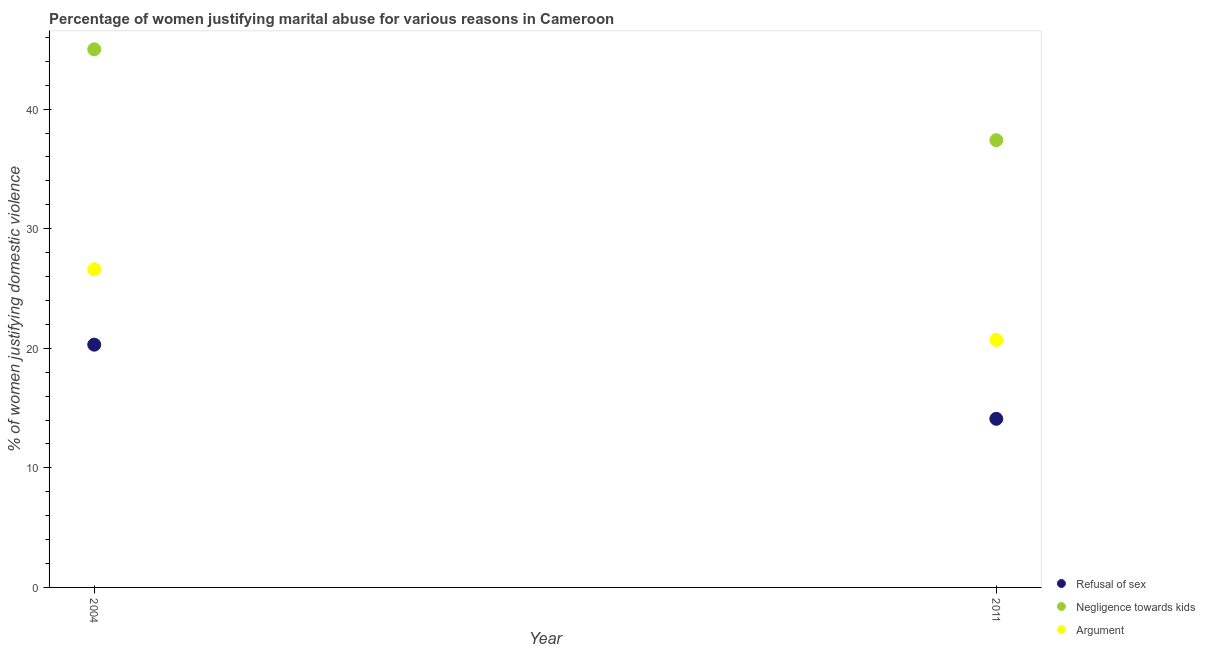Is the number of dotlines equal to the number of legend labels?
Ensure brevity in your answer.  Yes. What is the percentage of women justifying domestic violence due to negligence towards kids in 2004?
Make the answer very short. 45. Across all years, what is the minimum percentage of women justifying domestic violence due to arguments?
Make the answer very short. 20.7. In which year was the percentage of women justifying domestic violence due to arguments maximum?
Offer a very short reply. 2004. In which year was the percentage of women justifying domestic violence due to refusal of sex minimum?
Provide a succinct answer. 2011. What is the total percentage of women justifying domestic violence due to negligence towards kids in the graph?
Make the answer very short. 82.4. What is the difference between the percentage of women justifying domestic violence due to negligence towards kids in 2004 and that in 2011?
Your answer should be very brief. 7.6. What is the difference between the percentage of women justifying domestic violence due to negligence towards kids in 2011 and the percentage of women justifying domestic violence due to arguments in 2004?
Offer a very short reply. 10.8. What is the average percentage of women justifying domestic violence due to arguments per year?
Your answer should be very brief. 23.65. In the year 2011, what is the difference between the percentage of women justifying domestic violence due to refusal of sex and percentage of women justifying domestic violence due to arguments?
Your response must be concise. -6.6. What is the ratio of the percentage of women justifying domestic violence due to arguments in 2004 to that in 2011?
Make the answer very short. 1.29. Is it the case that in every year, the sum of the percentage of women justifying domestic violence due to refusal of sex and percentage of women justifying domestic violence due to negligence towards kids is greater than the percentage of women justifying domestic violence due to arguments?
Provide a short and direct response. Yes. Does the percentage of women justifying domestic violence due to negligence towards kids monotonically increase over the years?
Provide a succinct answer. No. Is the percentage of women justifying domestic violence due to negligence towards kids strictly greater than the percentage of women justifying domestic violence due to refusal of sex over the years?
Offer a very short reply. Yes. How many years are there in the graph?
Ensure brevity in your answer.  2. What is the difference between two consecutive major ticks on the Y-axis?
Offer a terse response. 10. Does the graph contain grids?
Provide a short and direct response. No. How many legend labels are there?
Make the answer very short. 3. How are the legend labels stacked?
Provide a short and direct response. Vertical. What is the title of the graph?
Keep it short and to the point. Percentage of women justifying marital abuse for various reasons in Cameroon. What is the label or title of the X-axis?
Ensure brevity in your answer.  Year. What is the label or title of the Y-axis?
Provide a short and direct response. % of women justifying domestic violence. What is the % of women justifying domestic violence of Refusal of sex in 2004?
Keep it short and to the point. 20.3. What is the % of women justifying domestic violence of Negligence towards kids in 2004?
Your answer should be compact. 45. What is the % of women justifying domestic violence of Argument in 2004?
Ensure brevity in your answer.  26.6. What is the % of women justifying domestic violence of Negligence towards kids in 2011?
Make the answer very short. 37.4. What is the % of women justifying domestic violence in Argument in 2011?
Your answer should be very brief. 20.7. Across all years, what is the maximum % of women justifying domestic violence in Refusal of sex?
Your response must be concise. 20.3. Across all years, what is the maximum % of women justifying domestic violence of Negligence towards kids?
Give a very brief answer. 45. Across all years, what is the maximum % of women justifying domestic violence of Argument?
Offer a terse response. 26.6. Across all years, what is the minimum % of women justifying domestic violence of Negligence towards kids?
Your response must be concise. 37.4. Across all years, what is the minimum % of women justifying domestic violence in Argument?
Make the answer very short. 20.7. What is the total % of women justifying domestic violence in Refusal of sex in the graph?
Make the answer very short. 34.4. What is the total % of women justifying domestic violence of Negligence towards kids in the graph?
Offer a terse response. 82.4. What is the total % of women justifying domestic violence in Argument in the graph?
Your response must be concise. 47.3. What is the difference between the % of women justifying domestic violence of Negligence towards kids in 2004 and that in 2011?
Offer a very short reply. 7.6. What is the difference between the % of women justifying domestic violence of Refusal of sex in 2004 and the % of women justifying domestic violence of Negligence towards kids in 2011?
Give a very brief answer. -17.1. What is the difference between the % of women justifying domestic violence in Refusal of sex in 2004 and the % of women justifying domestic violence in Argument in 2011?
Give a very brief answer. -0.4. What is the difference between the % of women justifying domestic violence of Negligence towards kids in 2004 and the % of women justifying domestic violence of Argument in 2011?
Give a very brief answer. 24.3. What is the average % of women justifying domestic violence in Negligence towards kids per year?
Your answer should be very brief. 41.2. What is the average % of women justifying domestic violence of Argument per year?
Your answer should be very brief. 23.65. In the year 2004, what is the difference between the % of women justifying domestic violence of Refusal of sex and % of women justifying domestic violence of Negligence towards kids?
Offer a very short reply. -24.7. In the year 2004, what is the difference between the % of women justifying domestic violence of Refusal of sex and % of women justifying domestic violence of Argument?
Ensure brevity in your answer.  -6.3. In the year 2004, what is the difference between the % of women justifying domestic violence in Negligence towards kids and % of women justifying domestic violence in Argument?
Your answer should be compact. 18.4. In the year 2011, what is the difference between the % of women justifying domestic violence of Refusal of sex and % of women justifying domestic violence of Negligence towards kids?
Provide a succinct answer. -23.3. In the year 2011, what is the difference between the % of women justifying domestic violence of Refusal of sex and % of women justifying domestic violence of Argument?
Keep it short and to the point. -6.6. What is the ratio of the % of women justifying domestic violence in Refusal of sex in 2004 to that in 2011?
Provide a short and direct response. 1.44. What is the ratio of the % of women justifying domestic violence of Negligence towards kids in 2004 to that in 2011?
Ensure brevity in your answer.  1.2. What is the ratio of the % of women justifying domestic violence of Argument in 2004 to that in 2011?
Keep it short and to the point. 1.28. What is the difference between the highest and the second highest % of women justifying domestic violence in Negligence towards kids?
Your answer should be compact. 7.6. What is the difference between the highest and the second highest % of women justifying domestic violence in Argument?
Make the answer very short. 5.9. 